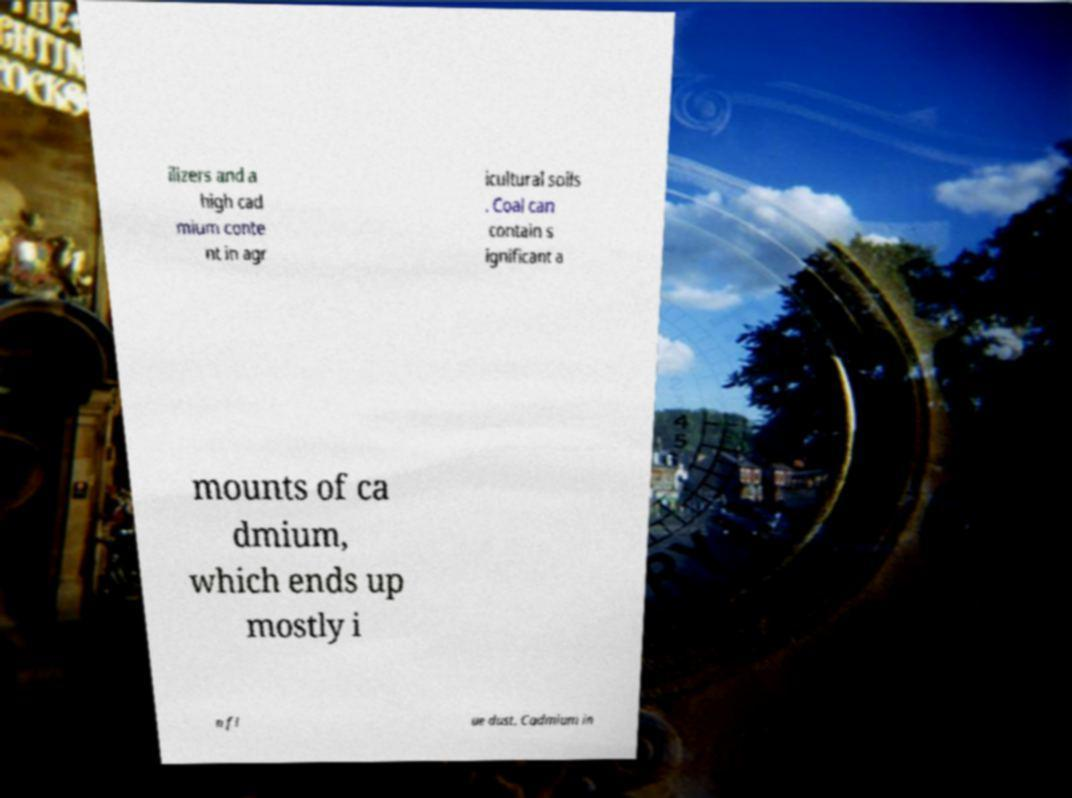Could you extract and type out the text from this image? ilizers and a high cad mium conte nt in agr icultural soils . Coal can contain s ignificant a mounts of ca dmium, which ends up mostly i n fl ue dust. Cadmium in 